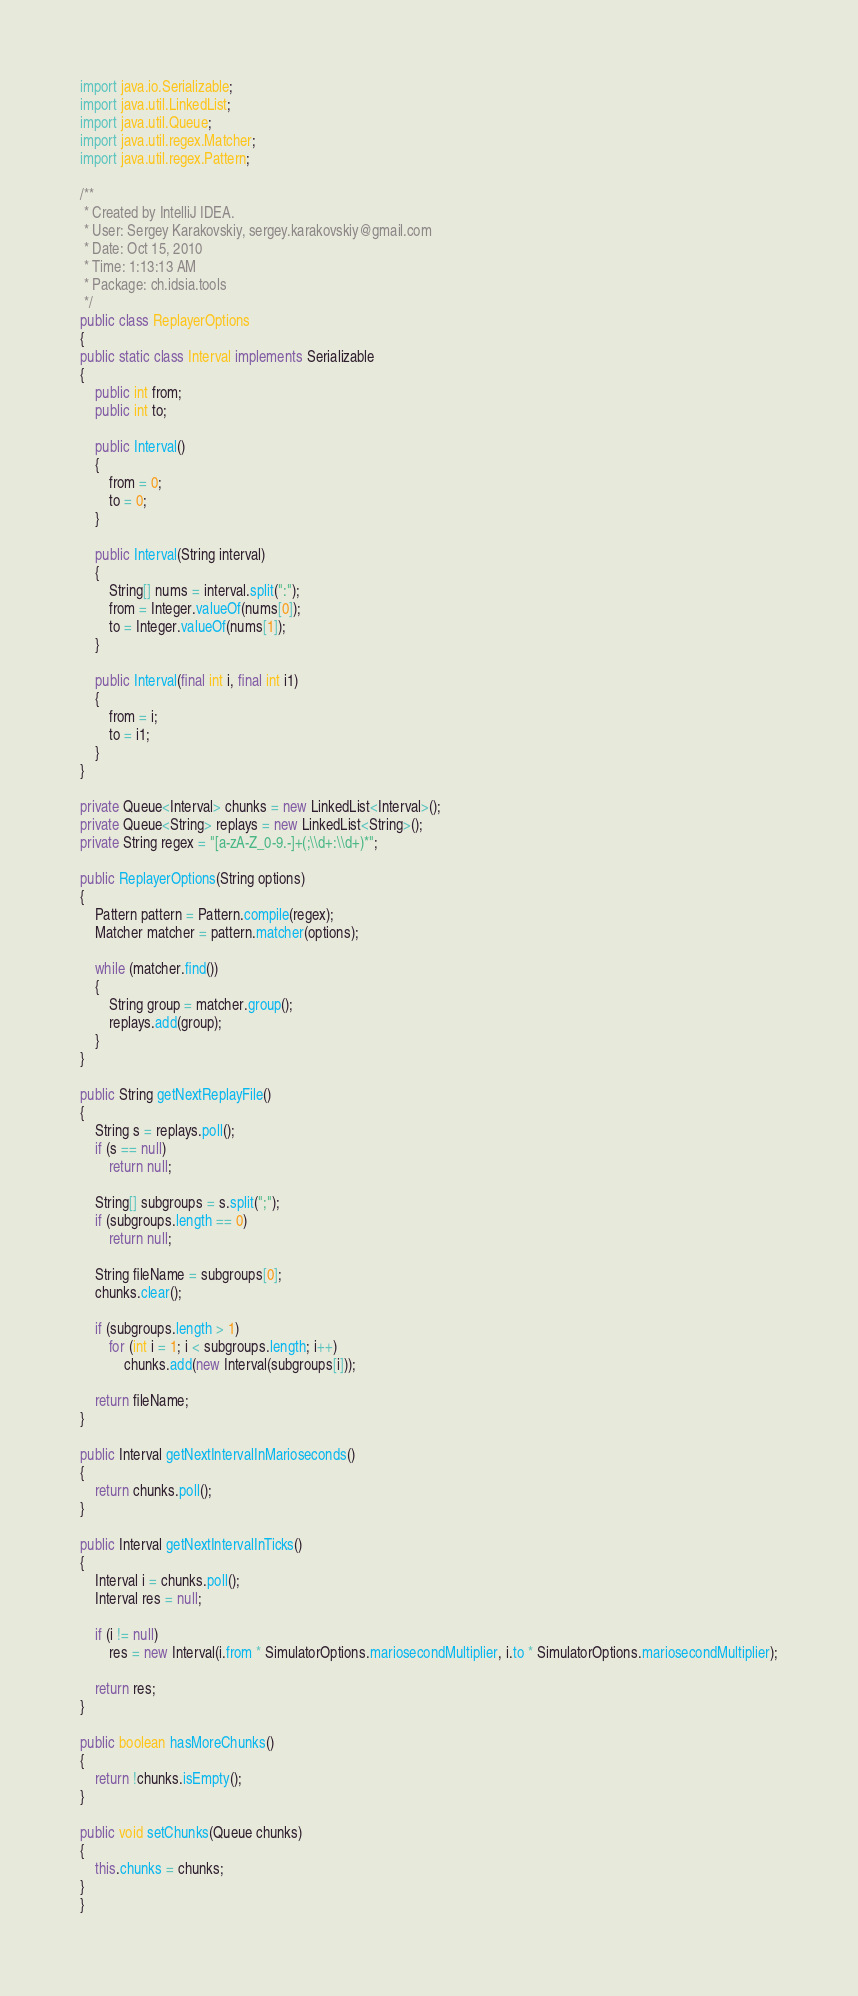Convert code to text. <code><loc_0><loc_0><loc_500><loc_500><_Java_>
import java.io.Serializable;
import java.util.LinkedList;
import java.util.Queue;
import java.util.regex.Matcher;
import java.util.regex.Pattern;

/**
 * Created by IntelliJ IDEA.
 * User: Sergey Karakovskiy, sergey.karakovskiy@gmail.com
 * Date: Oct 15, 2010
 * Time: 1:13:13 AM
 * Package: ch.idsia.tools
 */
public class ReplayerOptions
{
public static class Interval implements Serializable
{
    public int from;
    public int to;

    public Interval()
    {
        from = 0;
        to = 0;
    }

    public Interval(String interval)
    {
        String[] nums = interval.split(":");
        from = Integer.valueOf(nums[0]);
        to = Integer.valueOf(nums[1]);
    }

    public Interval(final int i, final int i1)
    {
        from = i;
        to = i1;
    }
}

private Queue<Interval> chunks = new LinkedList<Interval>();
private Queue<String> replays = new LinkedList<String>();
private String regex = "[a-zA-Z_0-9.-]+(;\\d+:\\d+)*";

public ReplayerOptions(String options)
{
    Pattern pattern = Pattern.compile(regex);
    Matcher matcher = pattern.matcher(options);

    while (matcher.find())
    {
        String group = matcher.group();
        replays.add(group);
    }
}

public String getNextReplayFile()
{
    String s = replays.poll();
    if (s == null)
        return null;

    String[] subgroups = s.split(";");
    if (subgroups.length == 0)
        return null;

    String fileName = subgroups[0];
    chunks.clear();

    if (subgroups.length > 1)
        for (int i = 1; i < subgroups.length; i++)
            chunks.add(new Interval(subgroups[i]));

    return fileName;
}

public Interval getNextIntervalInMarioseconds()
{
    return chunks.poll();
}

public Interval getNextIntervalInTicks()
{
    Interval i = chunks.poll();
    Interval res = null;

    if (i != null)
        res = new Interval(i.from * SimulatorOptions.mariosecondMultiplier, i.to * SimulatorOptions.mariosecondMultiplier);

    return res;
}

public boolean hasMoreChunks()
{
    return !chunks.isEmpty();
}

public void setChunks(Queue chunks)
{
    this.chunks = chunks;
}
}
</code> 